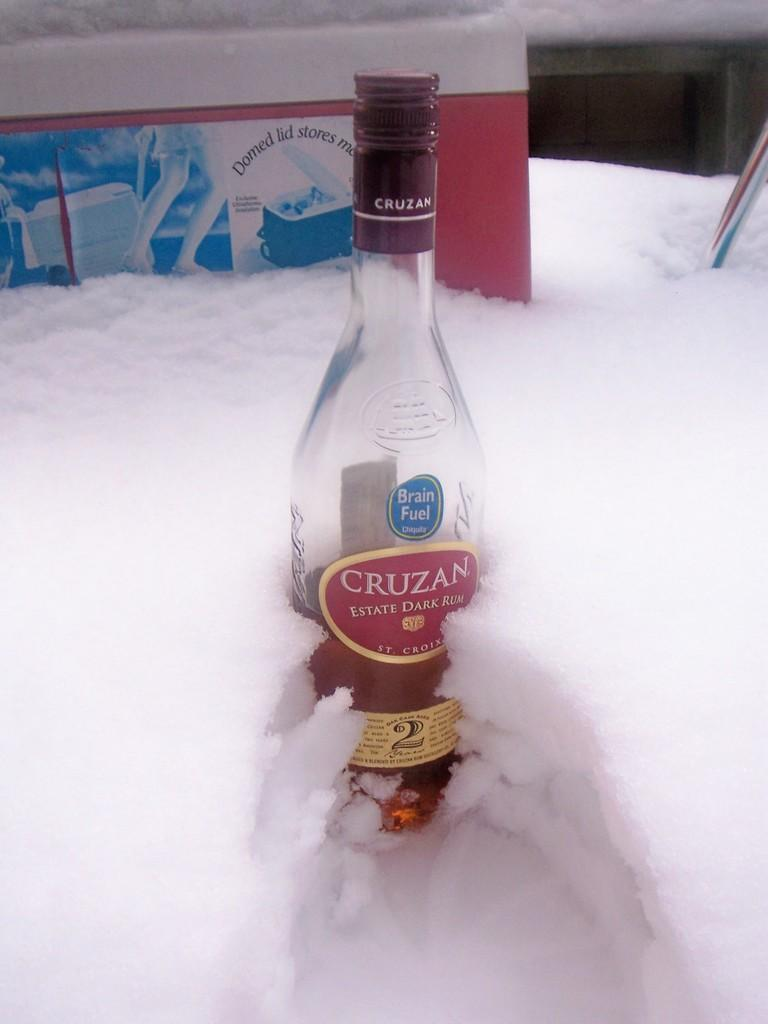<image>
Summarize the visual content of the image. A bottle of Cruzan dark rum siting in the snow. 